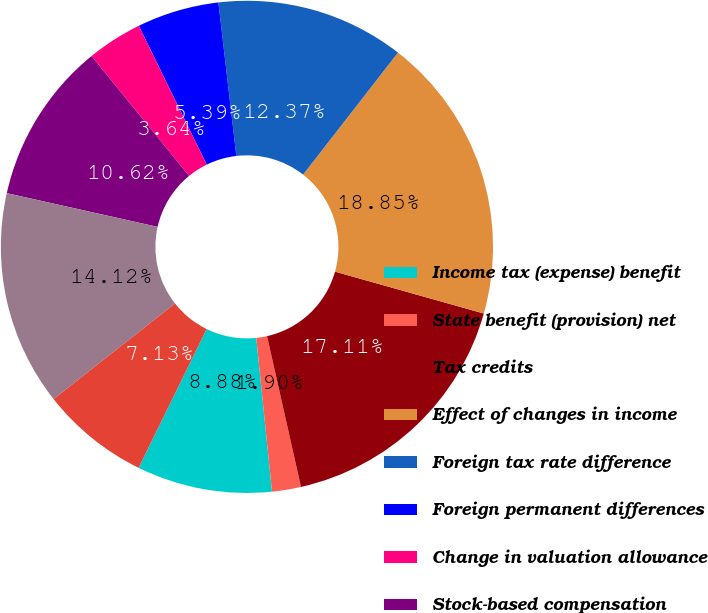Convert chart. <chart><loc_0><loc_0><loc_500><loc_500><pie_chart><fcel>Income tax (expense) benefit<fcel>State benefit (provision) net<fcel>Tax credits<fcel>Effect of changes in income<fcel>Foreign tax rate difference<fcel>Foreign permanent differences<fcel>Change in valuation allowance<fcel>Stock-based compensation<fcel>Tax reserve adjustments<fcel>Actual and deemed dividend<nl><fcel>8.88%<fcel>1.9%<fcel>17.11%<fcel>18.85%<fcel>12.37%<fcel>5.39%<fcel>3.64%<fcel>10.62%<fcel>14.12%<fcel>7.13%<nl></chart> 